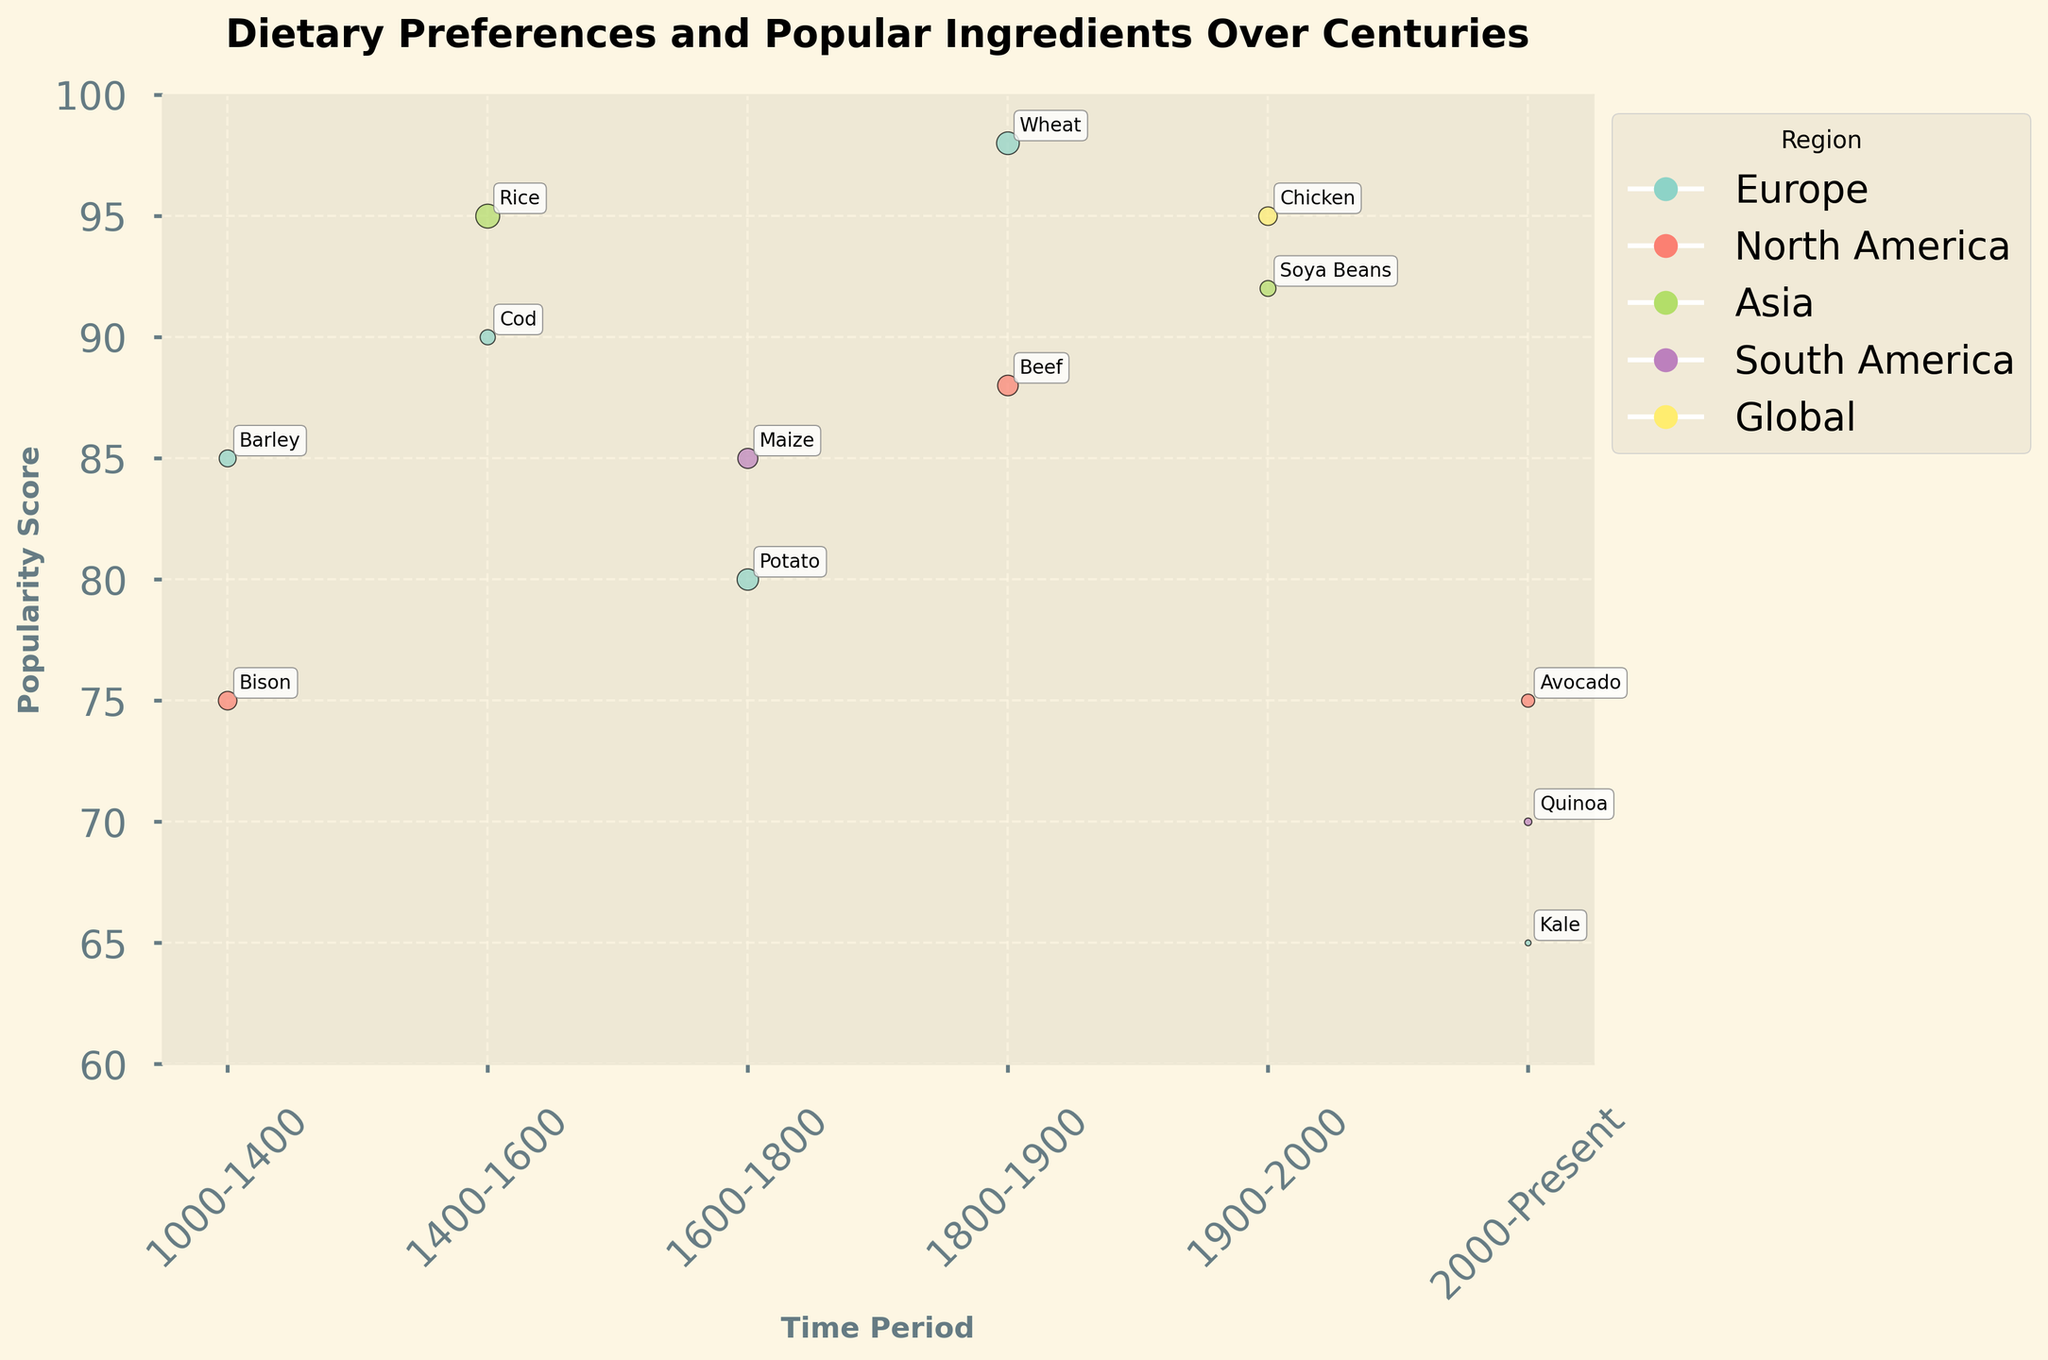What is the title of the figure? The title is written at the top of the figure.
Answer: "Dietary Preferences and Popular Ingredients Over Centuries" What regions are represented in the data? The regions are shown in the legend to the right of the figure.
Answer: Europe, North America, Asia, South America, Global Which ingredient from the 2000-Present period has the highest average consumption? Comparing the bubble sizes for Quinoa, Avocado, and Kale in the 2000-Present period, Avocado has the largest bubble indicating the highest average consumption.
Answer: Avocado Which time period features the ingredient with the highest popularity score? By checking the y-axis values, Wheat from the 1800-1900 period has the highest popularity score of 98.
Answer: 1800-1900 Which ingredient has the lowest popularity score in the 2000-Present period? Comparing the y-axis values for Quinoa, Avocado, and Kale, Kale has the lowest popularity score of 65.
Answer: Kale How many ingredients are represented for the time period 1900-2000? Identify the bubbles for ingredients Soya Beans and Chicken from 1900-2000 period.
Answer: 2 Out of all the time periods shown, which one has the most diverse set of regions represented? Look at the legend and the bubbles for each period to count the unique regions represented. The 2000-Present period has three unique regions: South America, North America, and Europe.
Answer: 2000-Present What is the sum of the popularity scores for the ingredients from Asia? Adding up the popularity scores for Rice (95) and Soya Beans (92) gives 95 + 92.
Answer: 187 Comparing the average consumption in grams, which ingredient differs most from the average consumption of Potato in 1600-1800 period? Potato has 400 grams. From visual comparison, Kale in the 2000-Present period has a much smaller bubble (30 grams). Difference is 400-30 = 370 grams.
Answer: Kale Which ingredient from Europe is most popular in the 1400-1600 period? Comparing the y-axis values for Cod and other European ingredients in this period, Cod has a popularity score of 90.
Answer: Cod 